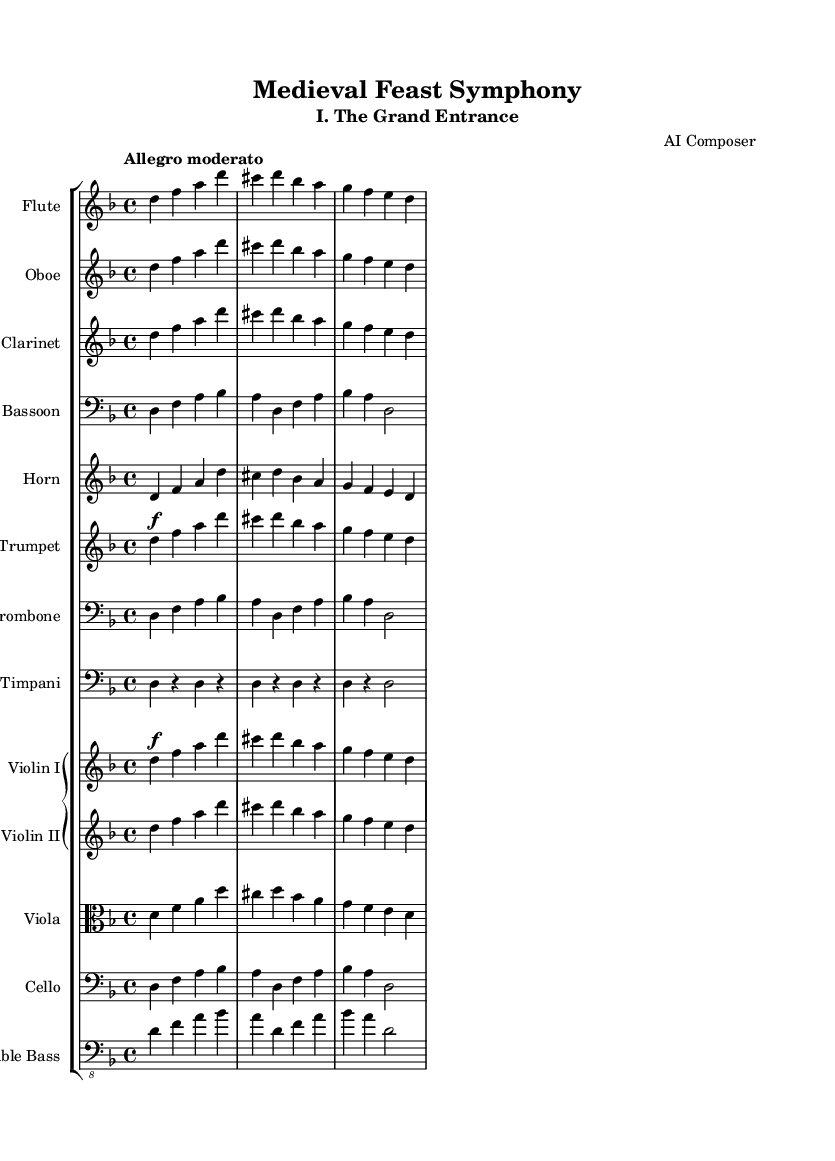What is the key signature of this music? The key signature is indicated at the beginning of the music where it shows two flats, which means it is in D minor.
Answer: D minor What is the time signature of the piece? The time signature is located at the beginning of the score, which is shown as 4/4, indicating four beats per measure.
Answer: 4/4 What is the tempo marking for this movement? The tempo is noted above the staff as "Allegro moderato," which indicates a moderately fast tempo.
Answer: Allegro moderato How many instruments are there in total? By counting each unique staff listed in the score, we have a total of 13 instruments, including woodwinds, brass, percussion, and strings.
Answer: 13 What is the dynamic marking for the first flute part? The dynamic marking appears right above the note during the flute's entrance, which states 'f' for forte, implying a loud sound.
Answer: f Which two instruments are playing the same melodic line in the opening section? By examining the staves, it can be noticed that both the flute and the oboe are playing identical notes throughout the initial measures.
Answer: Flute, Oboe What is the last note of the cello part in the first measure? The last note of the cello part in the first measure is a 'bes', which can be found at the end of the measure in the cello staff.
Answer: bes 